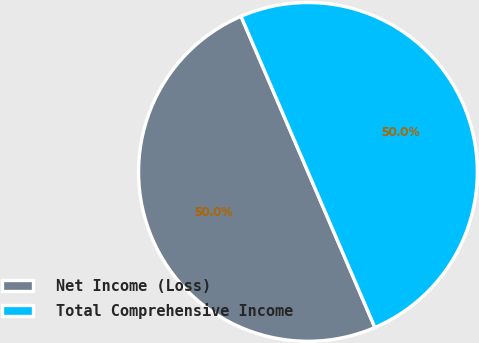Convert chart. <chart><loc_0><loc_0><loc_500><loc_500><pie_chart><fcel>Net Income (Loss)<fcel>Total Comprehensive Income<nl><fcel>50.0%<fcel>50.0%<nl></chart> 